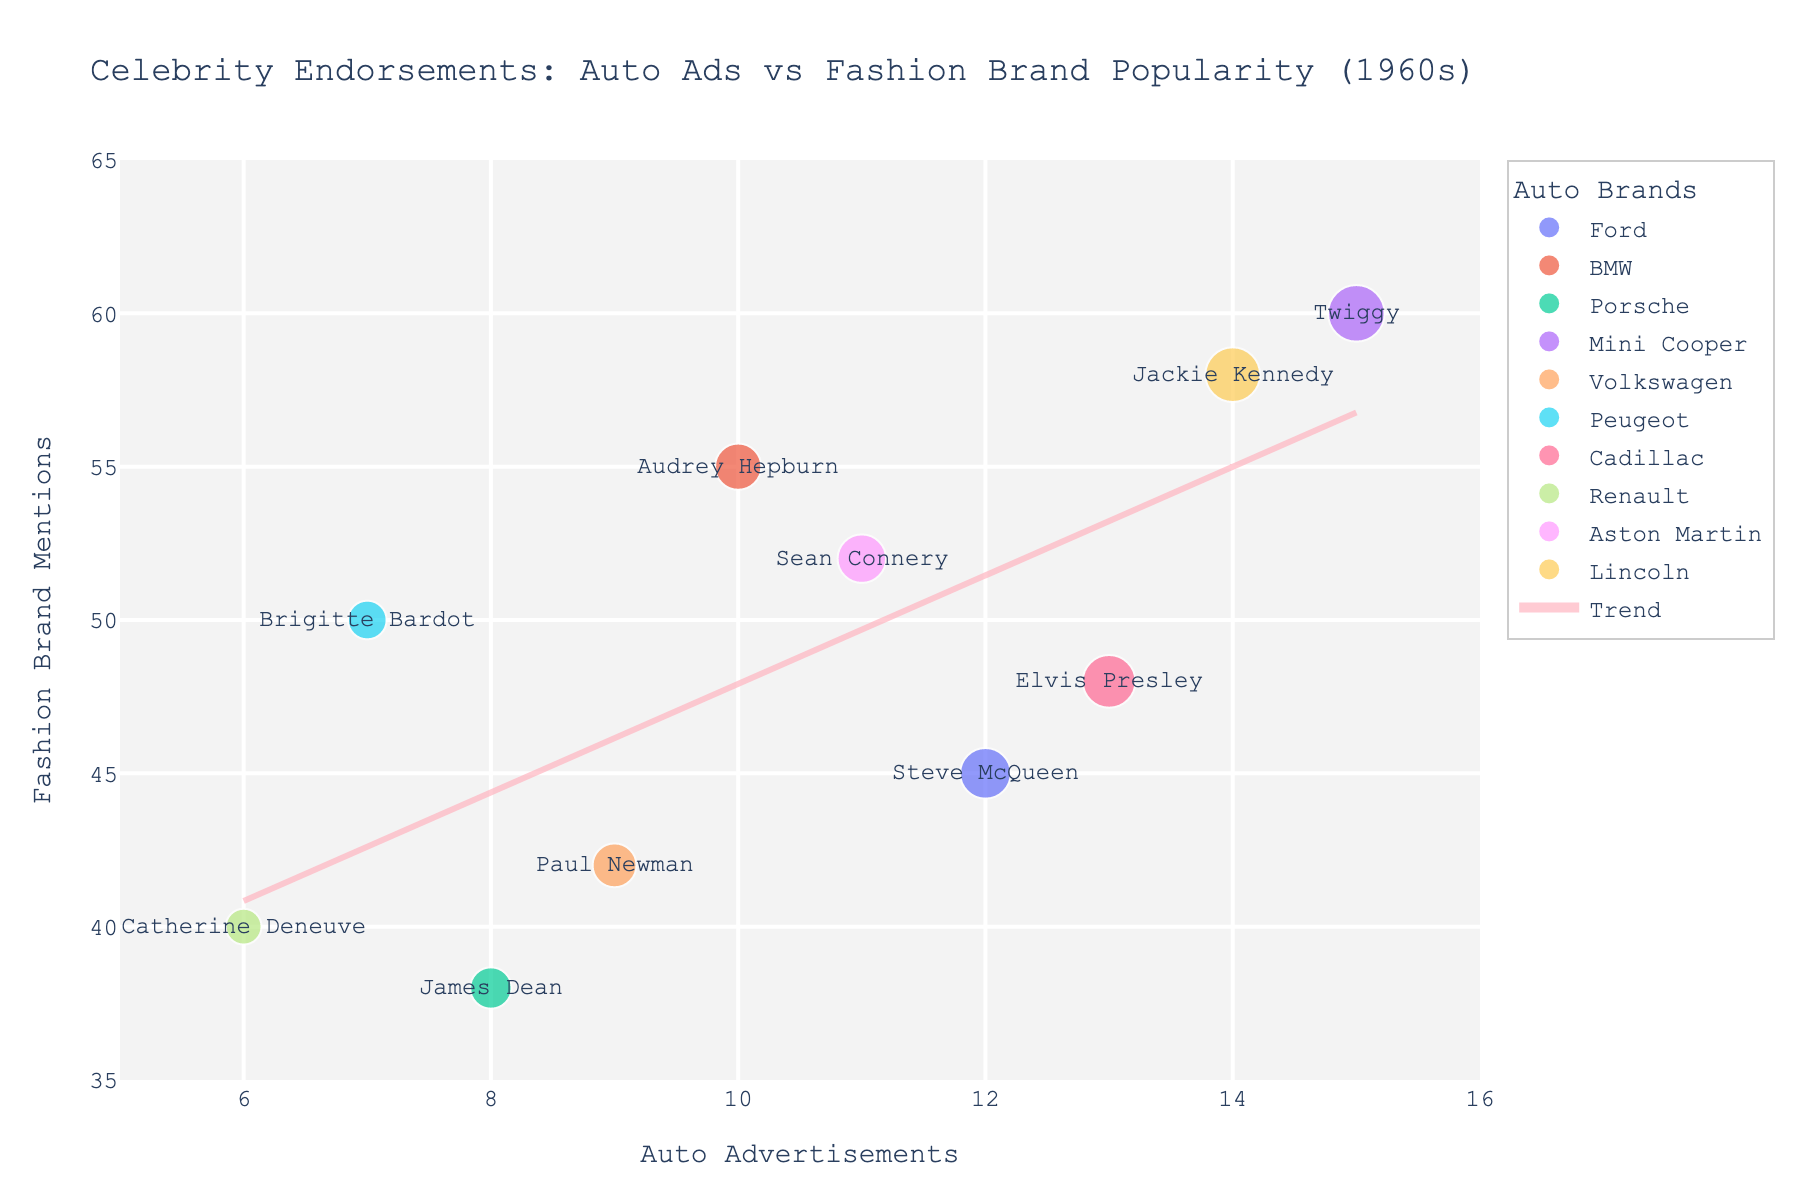What is the title of the scatter plot? The title is shown at the top of the figure, it usually provides an idea of what the plot is about.
Answer: Celebrity Endorsements: Auto Ads vs Fashion Brand Popularity (1960s) How many data points are present in the scatter plot? Each data point represents a celebrity, and there are as many points as there are celebrities listed in the data set.
Answer: 10 Which celebrity has the highest number of fashion brand mentions? Look for the data point farthest along the y-axis, then check the corresponding label or hover text.
Answer: Twiggy Which auto brand is associated with the celebrity who participated in the most auto ads? Identify the data point farthest along the x-axis, then check the corresponding auto brand label.
Answer: Mini Cooper What is the trend indicated by the trend line in the scatter plot? The trend line shows the general relationship between the number of auto ads and the number of fashion brand mentions. If it slopes upward, it indicates a positive correlation.
Answer: Positive correlation How do the fashion brand mentions for Audrey Hepburn compare to those for Sean Connery? Find the positions of both data points on the y-axis and compare their values.
Answer: Audrey Hepburn has more mentions What is the average number of fashion brand mentions across all celebrities? Sum all the y-axis values (fashion mentions) and divide by the number of data points (10). (45 + 55 + 38 + 60 + 42 + 50 + 48 + 40 + 52 + 58) / 10 = 448 / 10 = 44.8
Answer: 44.8 Which two celebrities have the closest number of fashion brand mentions? Identify and compare the fashion mentions (y-axis values) to find the smallest difference. Elvis Presley and Catherine Deneuve both concentrate around 48 and 40 mentions.
Answer: Elvis Presley and Catherine Deneuve Among the listed celebrities, who has promoted Renault, and how many fashion brand mentions does this celebrity have? Look for the data point labeled "Renault" and check the corresponding fashion brand mentions value on the y-axis.
Answer: Catherine Deneuve, 40 mentions Is there any overlap between auto brands and fashion brands endorsed by the same celebrity? Compare the auto brands and fashion brands listed for each data point; check if any brand name appears in both categories.
Answer: No 